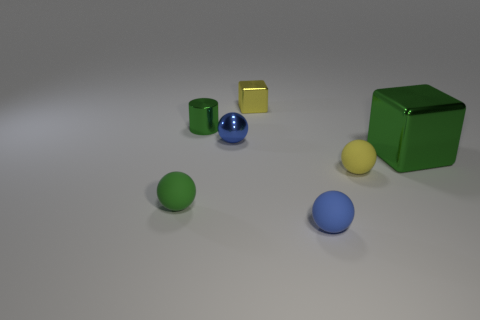Add 2 tiny blue things. How many objects exist? 9 Subtract all balls. How many objects are left? 3 Add 4 tiny balls. How many tiny balls exist? 8 Subtract 1 green balls. How many objects are left? 6 Subtract all small green metallic cubes. Subtract all small yellow rubber spheres. How many objects are left? 6 Add 3 small yellow objects. How many small yellow objects are left? 5 